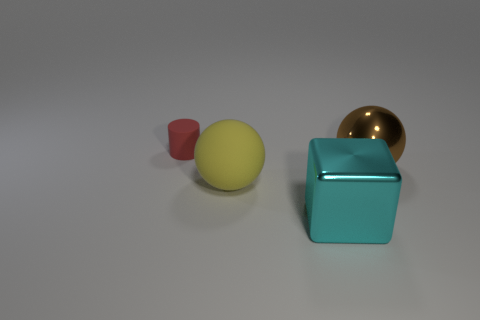Subtract all yellow balls. How many balls are left? 1 Add 3 yellow matte blocks. How many objects exist? 7 Subtract all blocks. How many objects are left? 3 Add 4 yellow matte things. How many yellow matte things exist? 5 Subtract 0 purple cylinders. How many objects are left? 4 Subtract all yellow balls. Subtract all cyan cylinders. How many balls are left? 1 Subtract all gray metallic things. Subtract all big yellow matte objects. How many objects are left? 3 Add 2 cyan metallic objects. How many cyan metallic objects are left? 3 